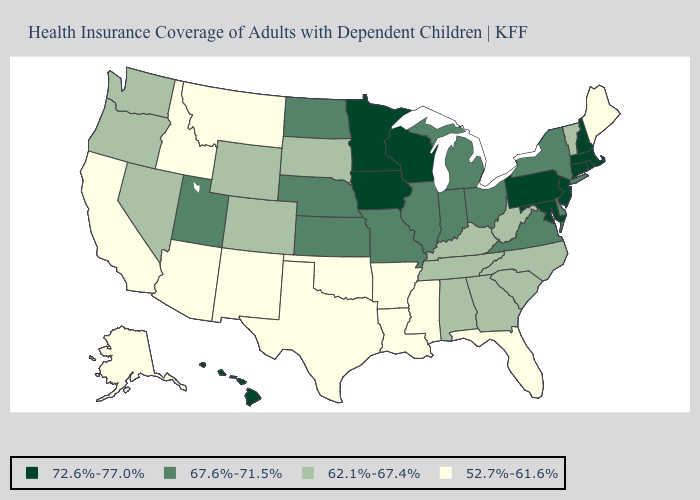Name the states that have a value in the range 72.6%-77.0%?
Concise answer only. Connecticut, Hawaii, Iowa, Maryland, Massachusetts, Minnesota, New Hampshire, New Jersey, Pennsylvania, Rhode Island, Wisconsin. What is the lowest value in the West?
Write a very short answer. 52.7%-61.6%. Does the first symbol in the legend represent the smallest category?
Write a very short answer. No. Does California have a lower value than Virginia?
Answer briefly. Yes. Name the states that have a value in the range 62.1%-67.4%?
Be succinct. Alabama, Colorado, Georgia, Kentucky, Nevada, North Carolina, Oregon, South Carolina, South Dakota, Tennessee, Vermont, Washington, West Virginia, Wyoming. What is the highest value in states that border Texas?
Keep it brief. 52.7%-61.6%. Which states hav the highest value in the West?
Keep it brief. Hawaii. Name the states that have a value in the range 67.6%-71.5%?
Quick response, please. Delaware, Illinois, Indiana, Kansas, Michigan, Missouri, Nebraska, New York, North Dakota, Ohio, Utah, Virginia. What is the value of North Carolina?
Write a very short answer. 62.1%-67.4%. What is the value of Utah?
Answer briefly. 67.6%-71.5%. Which states have the lowest value in the USA?
Quick response, please. Alaska, Arizona, Arkansas, California, Florida, Idaho, Louisiana, Maine, Mississippi, Montana, New Mexico, Oklahoma, Texas. What is the highest value in states that border South Carolina?
Write a very short answer. 62.1%-67.4%. Does Ohio have the lowest value in the USA?
Write a very short answer. No. Among the states that border New Jersey , which have the highest value?
Concise answer only. Pennsylvania. Does Colorado have the highest value in the USA?
Short answer required. No. 